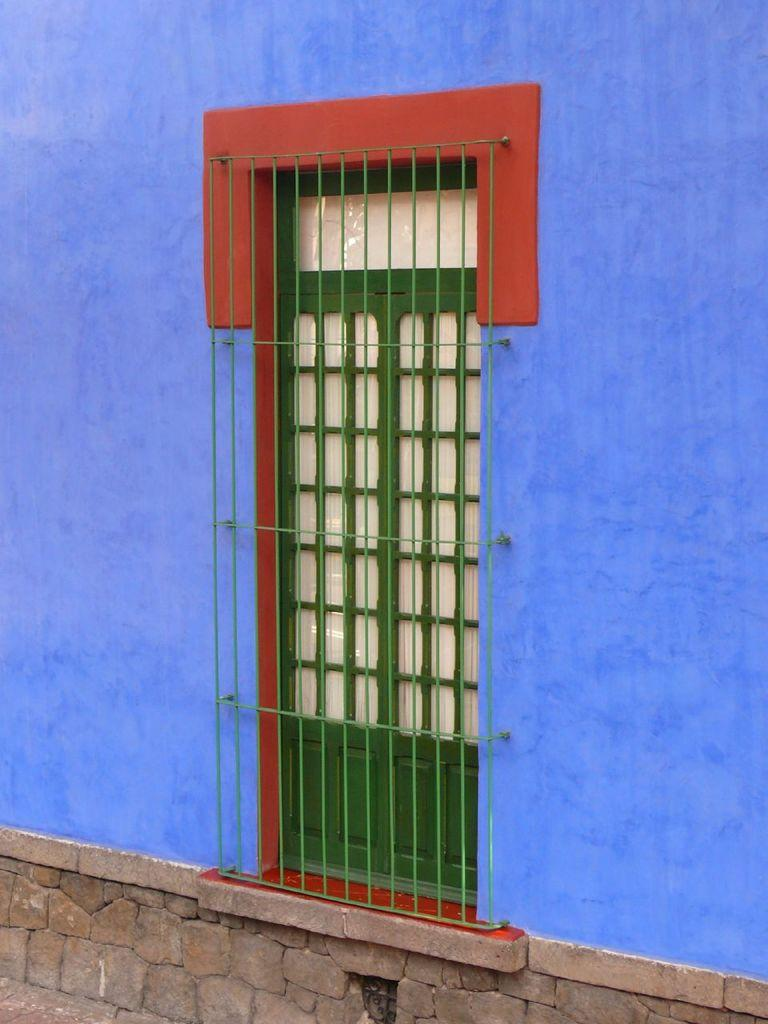What is the main subject in the center of the image? There is a door in the center of the image. What can be seen behind the door in the image? There is a wall in the background of the image. What type of knee injury is visible on the partner in the image? There is no partner or knee injury present in the image; it only features a door and a wall. 